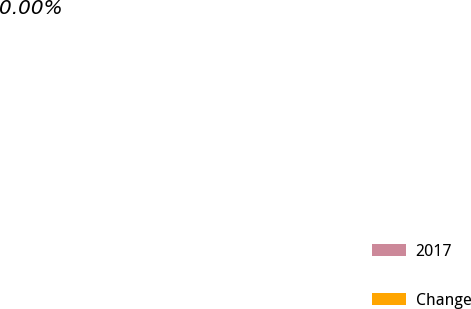Convert chart. <chart><loc_0><loc_0><loc_500><loc_500><pie_chart><fcel>2017<fcel>Change<nl><fcel>100.0%<fcel>0.0%<nl></chart> 